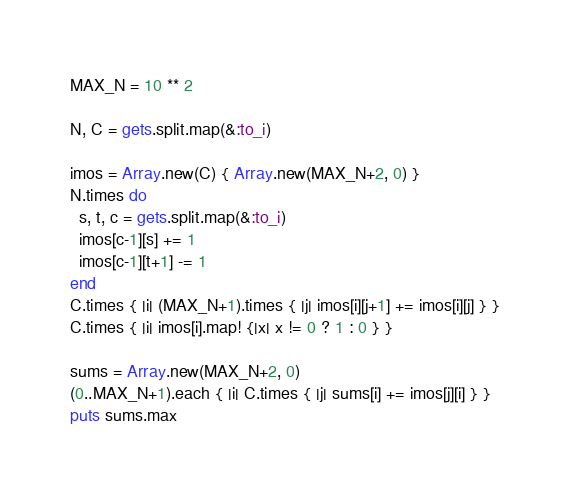Convert code to text. <code><loc_0><loc_0><loc_500><loc_500><_Ruby_>MAX_N = 10 ** 2

N, C = gets.split.map(&:to_i)

imos = Array.new(C) { Array.new(MAX_N+2, 0) }
N.times do
  s, t, c = gets.split.map(&:to_i)
  imos[c-1][s] += 1
  imos[c-1][t+1] -= 1
end
C.times { |i| (MAX_N+1).times { |j| imos[i][j+1] += imos[i][j] } }
C.times { |i| imos[i].map! {|x| x != 0 ? 1 : 0 } }

sums = Array.new(MAX_N+2, 0)
(0..MAX_N+1).each { |i| C.times { |j| sums[i] += imos[j][i] } }
puts sums.max
</code> 